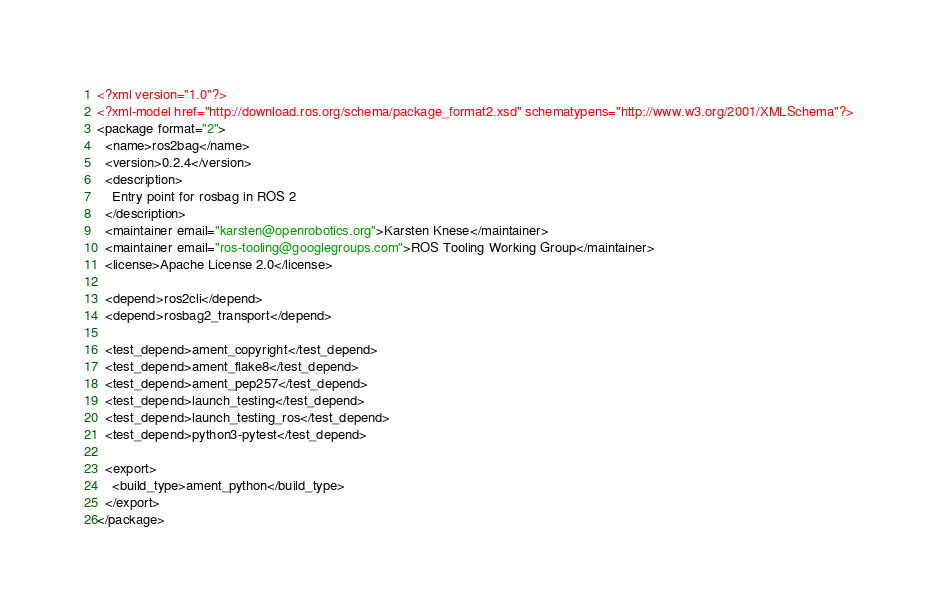<code> <loc_0><loc_0><loc_500><loc_500><_XML_><?xml version="1.0"?>
<?xml-model href="http://download.ros.org/schema/package_format2.xsd" schematypens="http://www.w3.org/2001/XMLSchema"?>
<package format="2">
  <name>ros2bag</name>
  <version>0.2.4</version>
  <description>
    Entry point for rosbag in ROS 2
  </description>
  <maintainer email="karsten@openrobotics.org">Karsten Knese</maintainer>
  <maintainer email="ros-tooling@googlegroups.com">ROS Tooling Working Group</maintainer>
  <license>Apache License 2.0</license>

  <depend>ros2cli</depend>
  <depend>rosbag2_transport</depend>

  <test_depend>ament_copyright</test_depend>
  <test_depend>ament_flake8</test_depend>
  <test_depend>ament_pep257</test_depend>
  <test_depend>launch_testing</test_depend>
  <test_depend>launch_testing_ros</test_depend>
  <test_depend>python3-pytest</test_depend>

  <export>
    <build_type>ament_python</build_type>
  </export>
</package>
</code> 